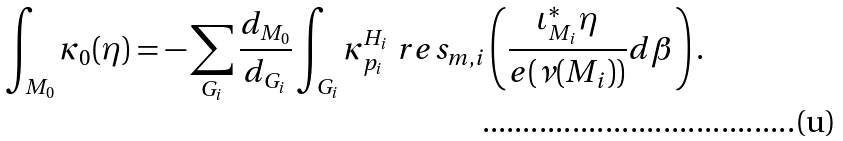<formula> <loc_0><loc_0><loc_500><loc_500>\int _ { M _ { 0 } } \kappa _ { 0 } ( \eta ) = - \sum _ { G _ { i } } \frac { d _ { M _ { 0 } } } { d _ { G _ { i } } } \int _ { G _ { i } } \kappa _ { p _ { i } } ^ { H _ { i } } \ r e s _ { m , i } \left ( \frac { \iota ^ { * } _ { M _ { i } } \eta } { e ( \nu ( M _ { i } ) ) } d \beta \right ) .</formula> 